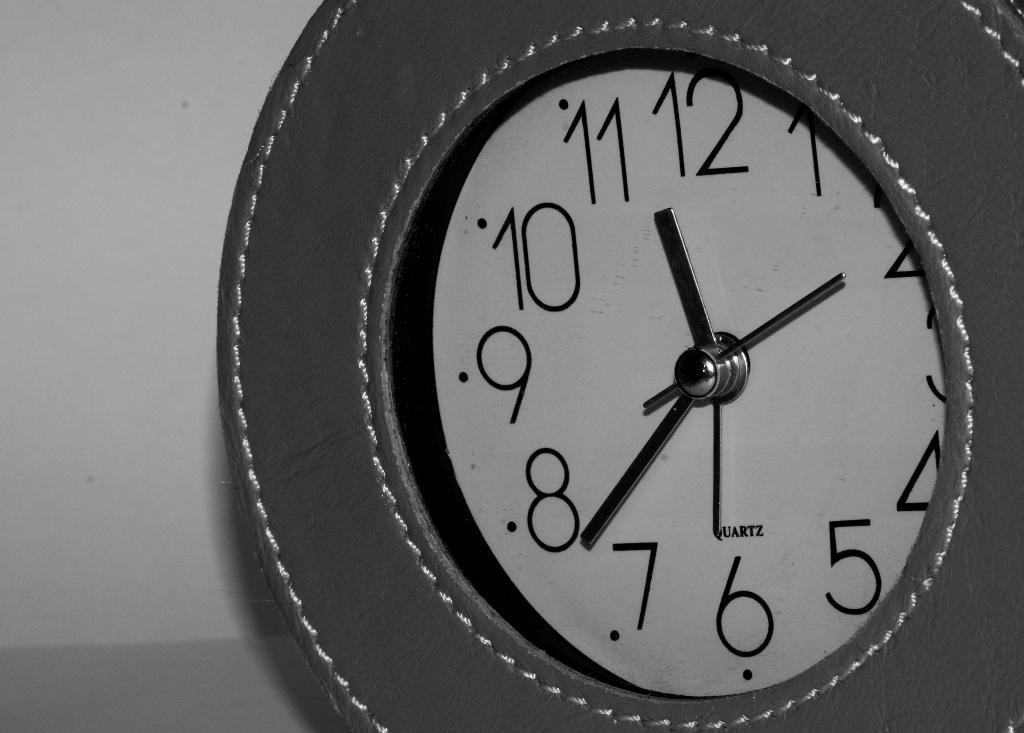What is the clock's time?
Keep it short and to the point. 11:38. What does the small text say above 6?
Make the answer very short. Quartz. 